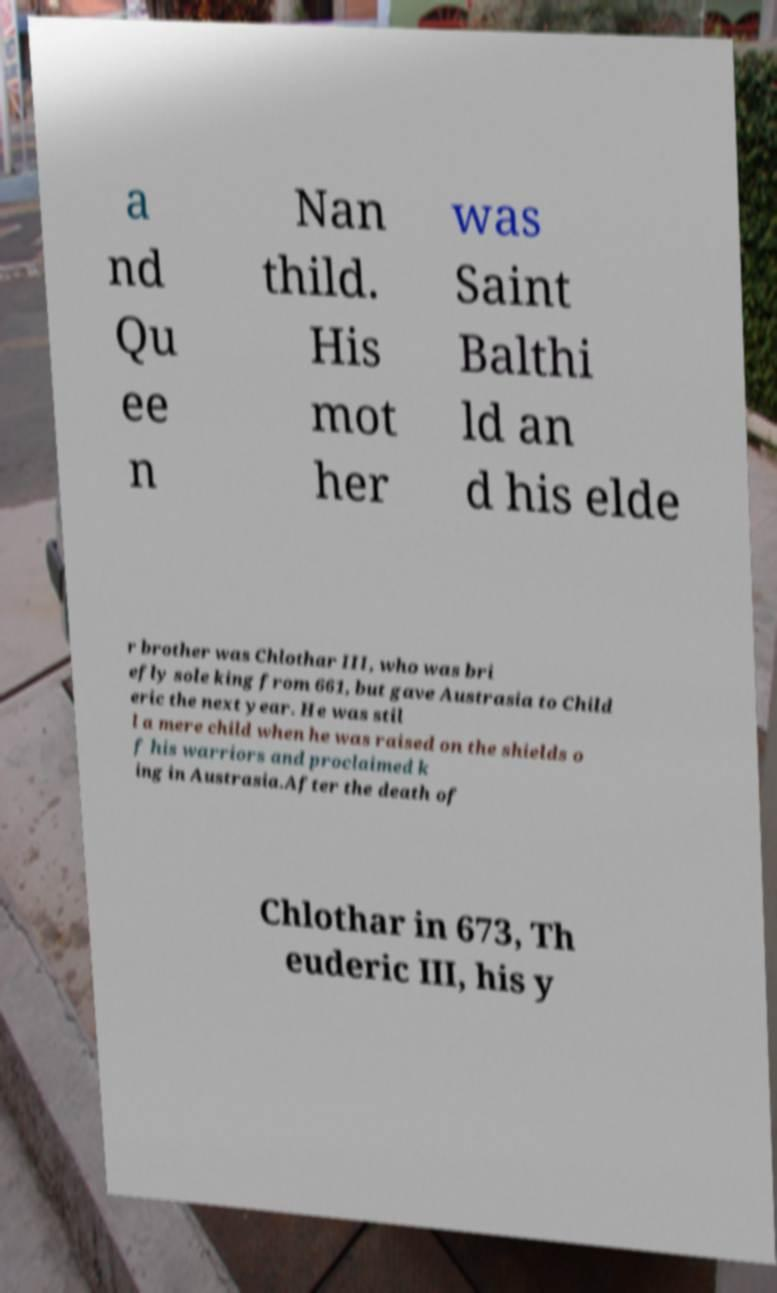Could you extract and type out the text from this image? a nd Qu ee n Nan thild. His mot her was Saint Balthi ld an d his elde r brother was Chlothar III, who was bri efly sole king from 661, but gave Austrasia to Child eric the next year. He was stil l a mere child when he was raised on the shields o f his warriors and proclaimed k ing in Austrasia.After the death of Chlothar in 673, Th euderic III, his y 